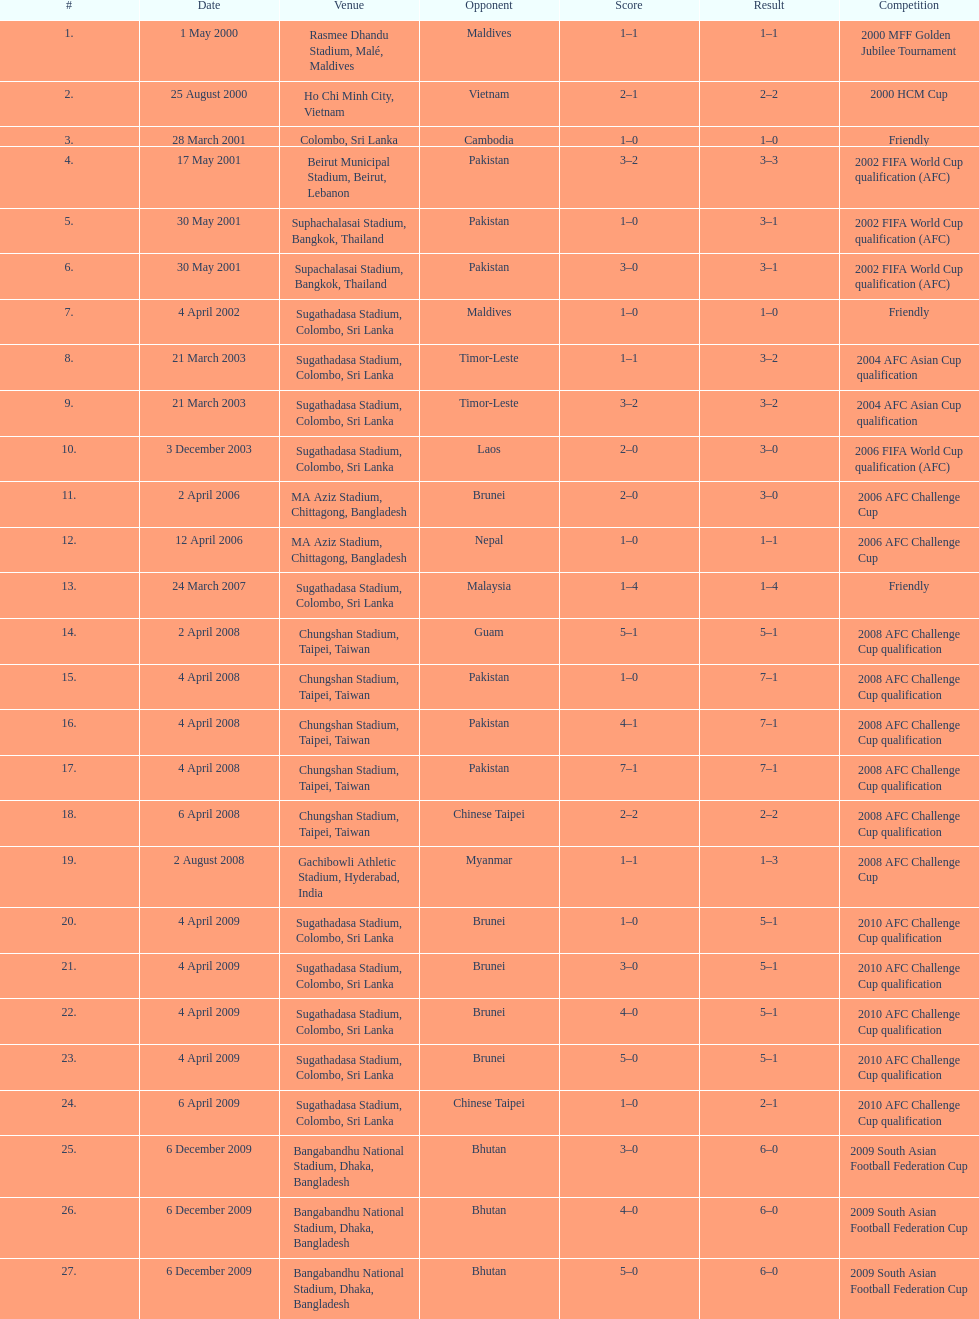What is the total count of games played against vietnam? 1. 